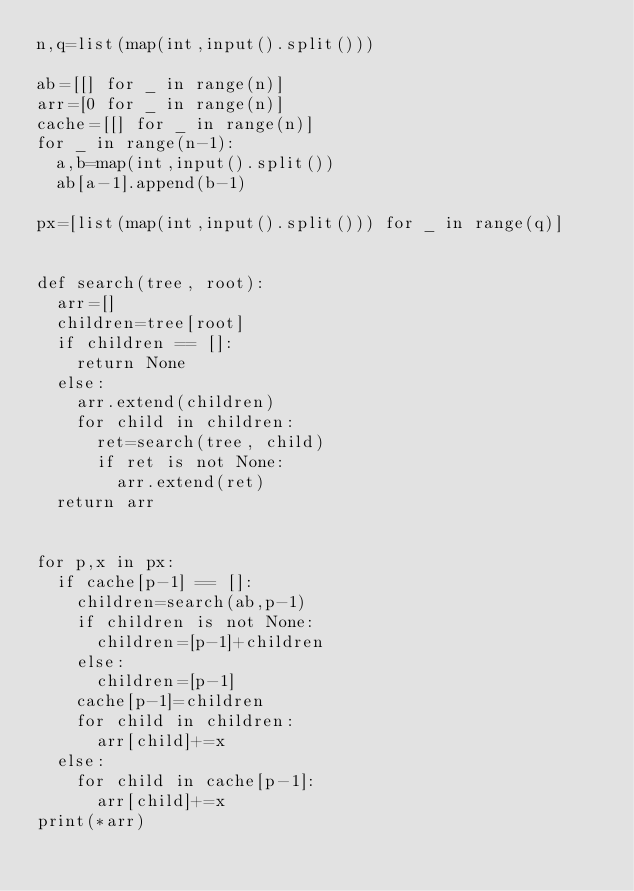<code> <loc_0><loc_0><loc_500><loc_500><_Python_>n,q=list(map(int,input().split()))

ab=[[] for _ in range(n)]
arr=[0 for _ in range(n)]
cache=[[] for _ in range(n)]
for _ in range(n-1):
  a,b=map(int,input().split())
  ab[a-1].append(b-1)

px=[list(map(int,input().split())) for _ in range(q)]
  
  
def search(tree, root):
  arr=[]
  children=tree[root]
  if children == []:
    return None
  else:
    arr.extend(children)
    for child in children:
      ret=search(tree, child)
      if ret is not None:
        arr.extend(ret)    
  return arr


for p,x in px:
  if cache[p-1] == []:
    children=search(ab,p-1)
    if children is not None:
      children=[p-1]+children
    else:
      children=[p-1]
    cache[p-1]=children
    for child in children:
      arr[child]+=x
  else:
    for child in cache[p-1]:
      arr[child]+=x    
print(*arr)
    </code> 